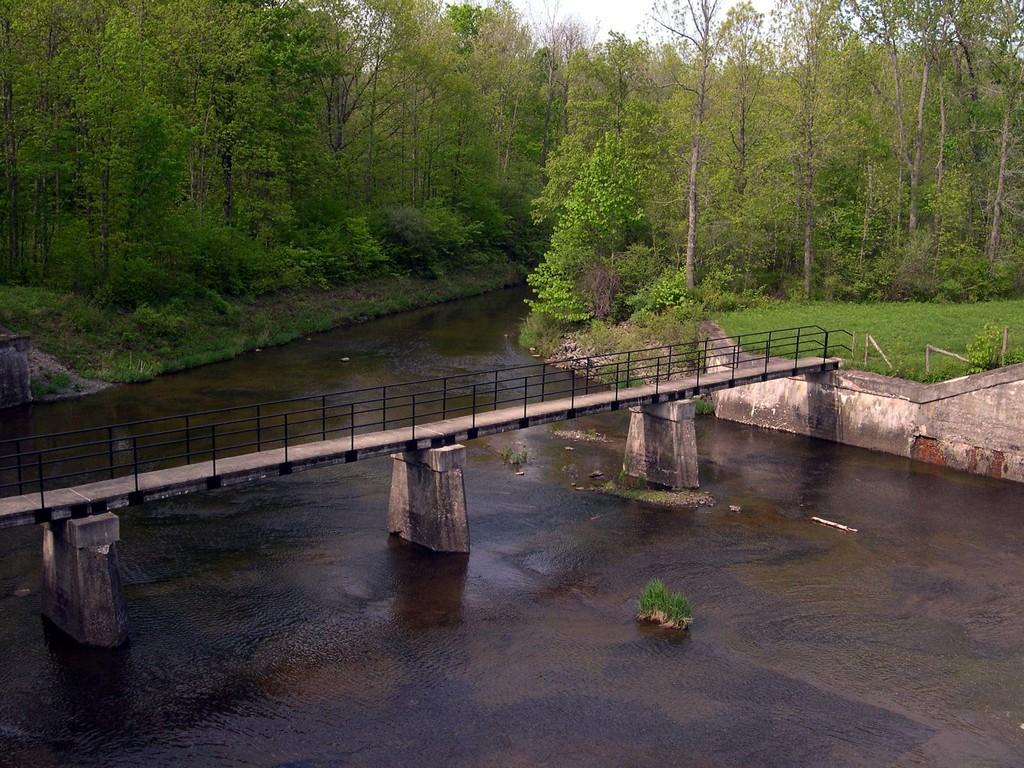How would you summarize this image in a sentence or two? In this image there is a river and some grass on the river, above the river there is a bridge. In the background there is a grass and trees. 